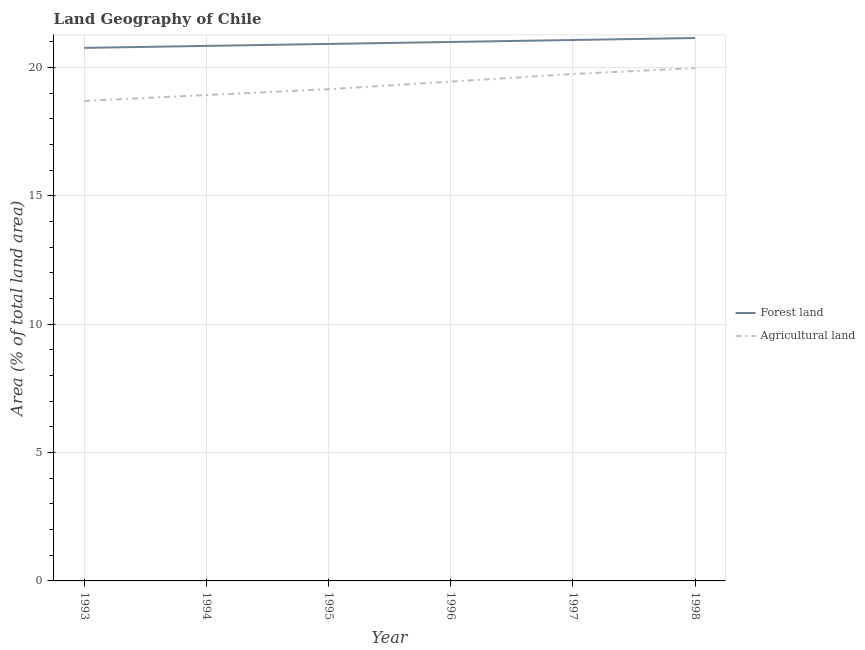Is the number of lines equal to the number of legend labels?
Make the answer very short. Yes. What is the percentage of land area under agriculture in 1993?
Keep it short and to the point. 18.69. Across all years, what is the maximum percentage of land area under agriculture?
Your answer should be compact. 19.97. Across all years, what is the minimum percentage of land area under agriculture?
Ensure brevity in your answer.  18.69. What is the total percentage of land area under agriculture in the graph?
Your response must be concise. 115.92. What is the difference between the percentage of land area under forests in 1996 and that in 1998?
Your answer should be very brief. -0.15. What is the difference between the percentage of land area under forests in 1997 and the percentage of land area under agriculture in 1993?
Make the answer very short. 2.37. What is the average percentage of land area under agriculture per year?
Provide a succinct answer. 19.32. In the year 1995, what is the difference between the percentage of land area under forests and percentage of land area under agriculture?
Keep it short and to the point. 1.76. What is the ratio of the percentage of land area under agriculture in 1993 to that in 1998?
Offer a terse response. 0.94. Is the percentage of land area under forests in 1994 less than that in 1998?
Provide a succinct answer. Yes. What is the difference between the highest and the second highest percentage of land area under agriculture?
Make the answer very short. 0.23. What is the difference between the highest and the lowest percentage of land area under agriculture?
Your response must be concise. 1.28. Is the sum of the percentage of land area under forests in 1994 and 1998 greater than the maximum percentage of land area under agriculture across all years?
Your response must be concise. Yes. Does the percentage of land area under forests monotonically increase over the years?
Offer a terse response. Yes. How many years are there in the graph?
Ensure brevity in your answer.  6. What is the difference between two consecutive major ticks on the Y-axis?
Provide a succinct answer. 5. Are the values on the major ticks of Y-axis written in scientific E-notation?
Keep it short and to the point. No. Does the graph contain grids?
Keep it short and to the point. Yes. How many legend labels are there?
Provide a short and direct response. 2. What is the title of the graph?
Give a very brief answer. Land Geography of Chile. What is the label or title of the X-axis?
Keep it short and to the point. Year. What is the label or title of the Y-axis?
Your response must be concise. Area (% of total land area). What is the Area (% of total land area) of Forest land in 1993?
Provide a succinct answer. 20.76. What is the Area (% of total land area) of Agricultural land in 1993?
Your response must be concise. 18.69. What is the Area (% of total land area) in Forest land in 1994?
Provide a short and direct response. 20.83. What is the Area (% of total land area) in Agricultural land in 1994?
Provide a short and direct response. 18.92. What is the Area (% of total land area) of Forest land in 1995?
Ensure brevity in your answer.  20.91. What is the Area (% of total land area) of Agricultural land in 1995?
Keep it short and to the point. 19.15. What is the Area (% of total land area) in Forest land in 1996?
Your response must be concise. 20.99. What is the Area (% of total land area) of Agricultural land in 1996?
Make the answer very short. 19.45. What is the Area (% of total land area) in Forest land in 1997?
Make the answer very short. 21.07. What is the Area (% of total land area) of Agricultural land in 1997?
Provide a succinct answer. 19.74. What is the Area (% of total land area) in Forest land in 1998?
Offer a very short reply. 21.14. What is the Area (% of total land area) in Agricultural land in 1998?
Keep it short and to the point. 19.97. Across all years, what is the maximum Area (% of total land area) in Forest land?
Your answer should be very brief. 21.14. Across all years, what is the maximum Area (% of total land area) of Agricultural land?
Make the answer very short. 19.97. Across all years, what is the minimum Area (% of total land area) of Forest land?
Provide a succinct answer. 20.76. Across all years, what is the minimum Area (% of total land area) of Agricultural land?
Offer a terse response. 18.69. What is the total Area (% of total land area) in Forest land in the graph?
Your response must be concise. 125.7. What is the total Area (% of total land area) in Agricultural land in the graph?
Your answer should be very brief. 115.92. What is the difference between the Area (% of total land area) in Forest land in 1993 and that in 1994?
Ensure brevity in your answer.  -0.08. What is the difference between the Area (% of total land area) in Agricultural land in 1993 and that in 1994?
Offer a very short reply. -0.23. What is the difference between the Area (% of total land area) in Forest land in 1993 and that in 1995?
Your answer should be very brief. -0.15. What is the difference between the Area (% of total land area) of Agricultural land in 1993 and that in 1995?
Provide a short and direct response. -0.46. What is the difference between the Area (% of total land area) in Forest land in 1993 and that in 1996?
Offer a terse response. -0.23. What is the difference between the Area (% of total land area) in Agricultural land in 1993 and that in 1996?
Keep it short and to the point. -0.75. What is the difference between the Area (% of total land area) in Forest land in 1993 and that in 1997?
Your answer should be very brief. -0.31. What is the difference between the Area (% of total land area) of Agricultural land in 1993 and that in 1997?
Keep it short and to the point. -1.05. What is the difference between the Area (% of total land area) in Forest land in 1993 and that in 1998?
Provide a succinct answer. -0.38. What is the difference between the Area (% of total land area) in Agricultural land in 1993 and that in 1998?
Make the answer very short. -1.28. What is the difference between the Area (% of total land area) in Forest land in 1994 and that in 1995?
Ensure brevity in your answer.  -0.08. What is the difference between the Area (% of total land area) of Agricultural land in 1994 and that in 1995?
Your answer should be very brief. -0.23. What is the difference between the Area (% of total land area) in Forest land in 1994 and that in 1996?
Offer a very short reply. -0.15. What is the difference between the Area (% of total land area) in Agricultural land in 1994 and that in 1996?
Your answer should be very brief. -0.52. What is the difference between the Area (% of total land area) in Forest land in 1994 and that in 1997?
Your answer should be compact. -0.23. What is the difference between the Area (% of total land area) in Agricultural land in 1994 and that in 1997?
Provide a short and direct response. -0.82. What is the difference between the Area (% of total land area) of Forest land in 1994 and that in 1998?
Provide a short and direct response. -0.31. What is the difference between the Area (% of total land area) in Agricultural land in 1994 and that in 1998?
Make the answer very short. -1.05. What is the difference between the Area (% of total land area) in Forest land in 1995 and that in 1996?
Your answer should be compact. -0.08. What is the difference between the Area (% of total land area) in Agricultural land in 1995 and that in 1996?
Make the answer very short. -0.3. What is the difference between the Area (% of total land area) in Forest land in 1995 and that in 1997?
Ensure brevity in your answer.  -0.15. What is the difference between the Area (% of total land area) in Agricultural land in 1995 and that in 1997?
Your answer should be compact. -0.59. What is the difference between the Area (% of total land area) of Forest land in 1995 and that in 1998?
Your answer should be compact. -0.23. What is the difference between the Area (% of total land area) in Agricultural land in 1995 and that in 1998?
Your answer should be very brief. -0.82. What is the difference between the Area (% of total land area) of Forest land in 1996 and that in 1997?
Provide a succinct answer. -0.08. What is the difference between the Area (% of total land area) of Agricultural land in 1996 and that in 1997?
Make the answer very short. -0.3. What is the difference between the Area (% of total land area) of Forest land in 1996 and that in 1998?
Offer a terse response. -0.15. What is the difference between the Area (% of total land area) in Agricultural land in 1996 and that in 1998?
Make the answer very short. -0.52. What is the difference between the Area (% of total land area) in Forest land in 1997 and that in 1998?
Your answer should be very brief. -0.08. What is the difference between the Area (% of total land area) of Agricultural land in 1997 and that in 1998?
Ensure brevity in your answer.  -0.23. What is the difference between the Area (% of total land area) in Forest land in 1993 and the Area (% of total land area) in Agricultural land in 1994?
Your response must be concise. 1.84. What is the difference between the Area (% of total land area) of Forest land in 1993 and the Area (% of total land area) of Agricultural land in 1995?
Your response must be concise. 1.61. What is the difference between the Area (% of total land area) of Forest land in 1993 and the Area (% of total land area) of Agricultural land in 1996?
Ensure brevity in your answer.  1.31. What is the difference between the Area (% of total land area) of Forest land in 1993 and the Area (% of total land area) of Agricultural land in 1997?
Your response must be concise. 1.02. What is the difference between the Area (% of total land area) in Forest land in 1993 and the Area (% of total land area) in Agricultural land in 1998?
Your answer should be compact. 0.79. What is the difference between the Area (% of total land area) in Forest land in 1994 and the Area (% of total land area) in Agricultural land in 1995?
Offer a very short reply. 1.69. What is the difference between the Area (% of total land area) in Forest land in 1994 and the Area (% of total land area) in Agricultural land in 1996?
Provide a succinct answer. 1.39. What is the difference between the Area (% of total land area) in Forest land in 1994 and the Area (% of total land area) in Agricultural land in 1997?
Your answer should be compact. 1.09. What is the difference between the Area (% of total land area) of Forest land in 1994 and the Area (% of total land area) of Agricultural land in 1998?
Give a very brief answer. 0.87. What is the difference between the Area (% of total land area) in Forest land in 1995 and the Area (% of total land area) in Agricultural land in 1996?
Provide a succinct answer. 1.47. What is the difference between the Area (% of total land area) of Forest land in 1995 and the Area (% of total land area) of Agricultural land in 1997?
Provide a succinct answer. 1.17. What is the difference between the Area (% of total land area) in Forest land in 1995 and the Area (% of total land area) in Agricultural land in 1998?
Your answer should be compact. 0.94. What is the difference between the Area (% of total land area) in Forest land in 1996 and the Area (% of total land area) in Agricultural land in 1997?
Your response must be concise. 1.25. What is the difference between the Area (% of total land area) in Forest land in 1996 and the Area (% of total land area) in Agricultural land in 1998?
Provide a succinct answer. 1.02. What is the difference between the Area (% of total land area) of Forest land in 1997 and the Area (% of total land area) of Agricultural land in 1998?
Keep it short and to the point. 1.1. What is the average Area (% of total land area) of Forest land per year?
Offer a very short reply. 20.95. What is the average Area (% of total land area) in Agricultural land per year?
Ensure brevity in your answer.  19.32. In the year 1993, what is the difference between the Area (% of total land area) of Forest land and Area (% of total land area) of Agricultural land?
Offer a terse response. 2.07. In the year 1994, what is the difference between the Area (% of total land area) of Forest land and Area (% of total land area) of Agricultural land?
Your answer should be compact. 1.91. In the year 1995, what is the difference between the Area (% of total land area) of Forest land and Area (% of total land area) of Agricultural land?
Keep it short and to the point. 1.76. In the year 1996, what is the difference between the Area (% of total land area) of Forest land and Area (% of total land area) of Agricultural land?
Provide a short and direct response. 1.54. In the year 1997, what is the difference between the Area (% of total land area) in Forest land and Area (% of total land area) in Agricultural land?
Provide a succinct answer. 1.32. In the year 1998, what is the difference between the Area (% of total land area) in Forest land and Area (% of total land area) in Agricultural land?
Your answer should be compact. 1.17. What is the ratio of the Area (% of total land area) of Agricultural land in 1993 to that in 1995?
Your answer should be compact. 0.98. What is the ratio of the Area (% of total land area) in Forest land in 1993 to that in 1996?
Give a very brief answer. 0.99. What is the ratio of the Area (% of total land area) in Agricultural land in 1993 to that in 1996?
Your answer should be very brief. 0.96. What is the ratio of the Area (% of total land area) of Forest land in 1993 to that in 1997?
Ensure brevity in your answer.  0.99. What is the ratio of the Area (% of total land area) in Agricultural land in 1993 to that in 1997?
Keep it short and to the point. 0.95. What is the ratio of the Area (% of total land area) in Forest land in 1993 to that in 1998?
Offer a terse response. 0.98. What is the ratio of the Area (% of total land area) in Agricultural land in 1993 to that in 1998?
Offer a terse response. 0.94. What is the ratio of the Area (% of total land area) in Forest land in 1994 to that in 1995?
Your answer should be very brief. 1. What is the ratio of the Area (% of total land area) of Agricultural land in 1994 to that in 1995?
Your response must be concise. 0.99. What is the ratio of the Area (% of total land area) in Forest land in 1994 to that in 1996?
Offer a very short reply. 0.99. What is the ratio of the Area (% of total land area) of Agricultural land in 1994 to that in 1996?
Your answer should be compact. 0.97. What is the ratio of the Area (% of total land area) of Agricultural land in 1994 to that in 1997?
Offer a very short reply. 0.96. What is the ratio of the Area (% of total land area) in Forest land in 1994 to that in 1998?
Keep it short and to the point. 0.99. What is the ratio of the Area (% of total land area) of Agricultural land in 1994 to that in 1998?
Ensure brevity in your answer.  0.95. What is the ratio of the Area (% of total land area) in Forest land in 1995 to that in 1996?
Your response must be concise. 1. What is the ratio of the Area (% of total land area) in Agricultural land in 1995 to that in 1996?
Give a very brief answer. 0.98. What is the ratio of the Area (% of total land area) of Forest land in 1995 to that in 1997?
Offer a very short reply. 0.99. What is the ratio of the Area (% of total land area) of Agricultural land in 1995 to that in 1998?
Keep it short and to the point. 0.96. What is the ratio of the Area (% of total land area) of Agricultural land in 1996 to that in 1997?
Offer a terse response. 0.98. What is the ratio of the Area (% of total land area) of Agricultural land in 1996 to that in 1998?
Your answer should be compact. 0.97. What is the difference between the highest and the second highest Area (% of total land area) in Forest land?
Offer a very short reply. 0.08. What is the difference between the highest and the second highest Area (% of total land area) of Agricultural land?
Offer a terse response. 0.23. What is the difference between the highest and the lowest Area (% of total land area) of Forest land?
Give a very brief answer. 0.38. What is the difference between the highest and the lowest Area (% of total land area) of Agricultural land?
Your answer should be compact. 1.28. 